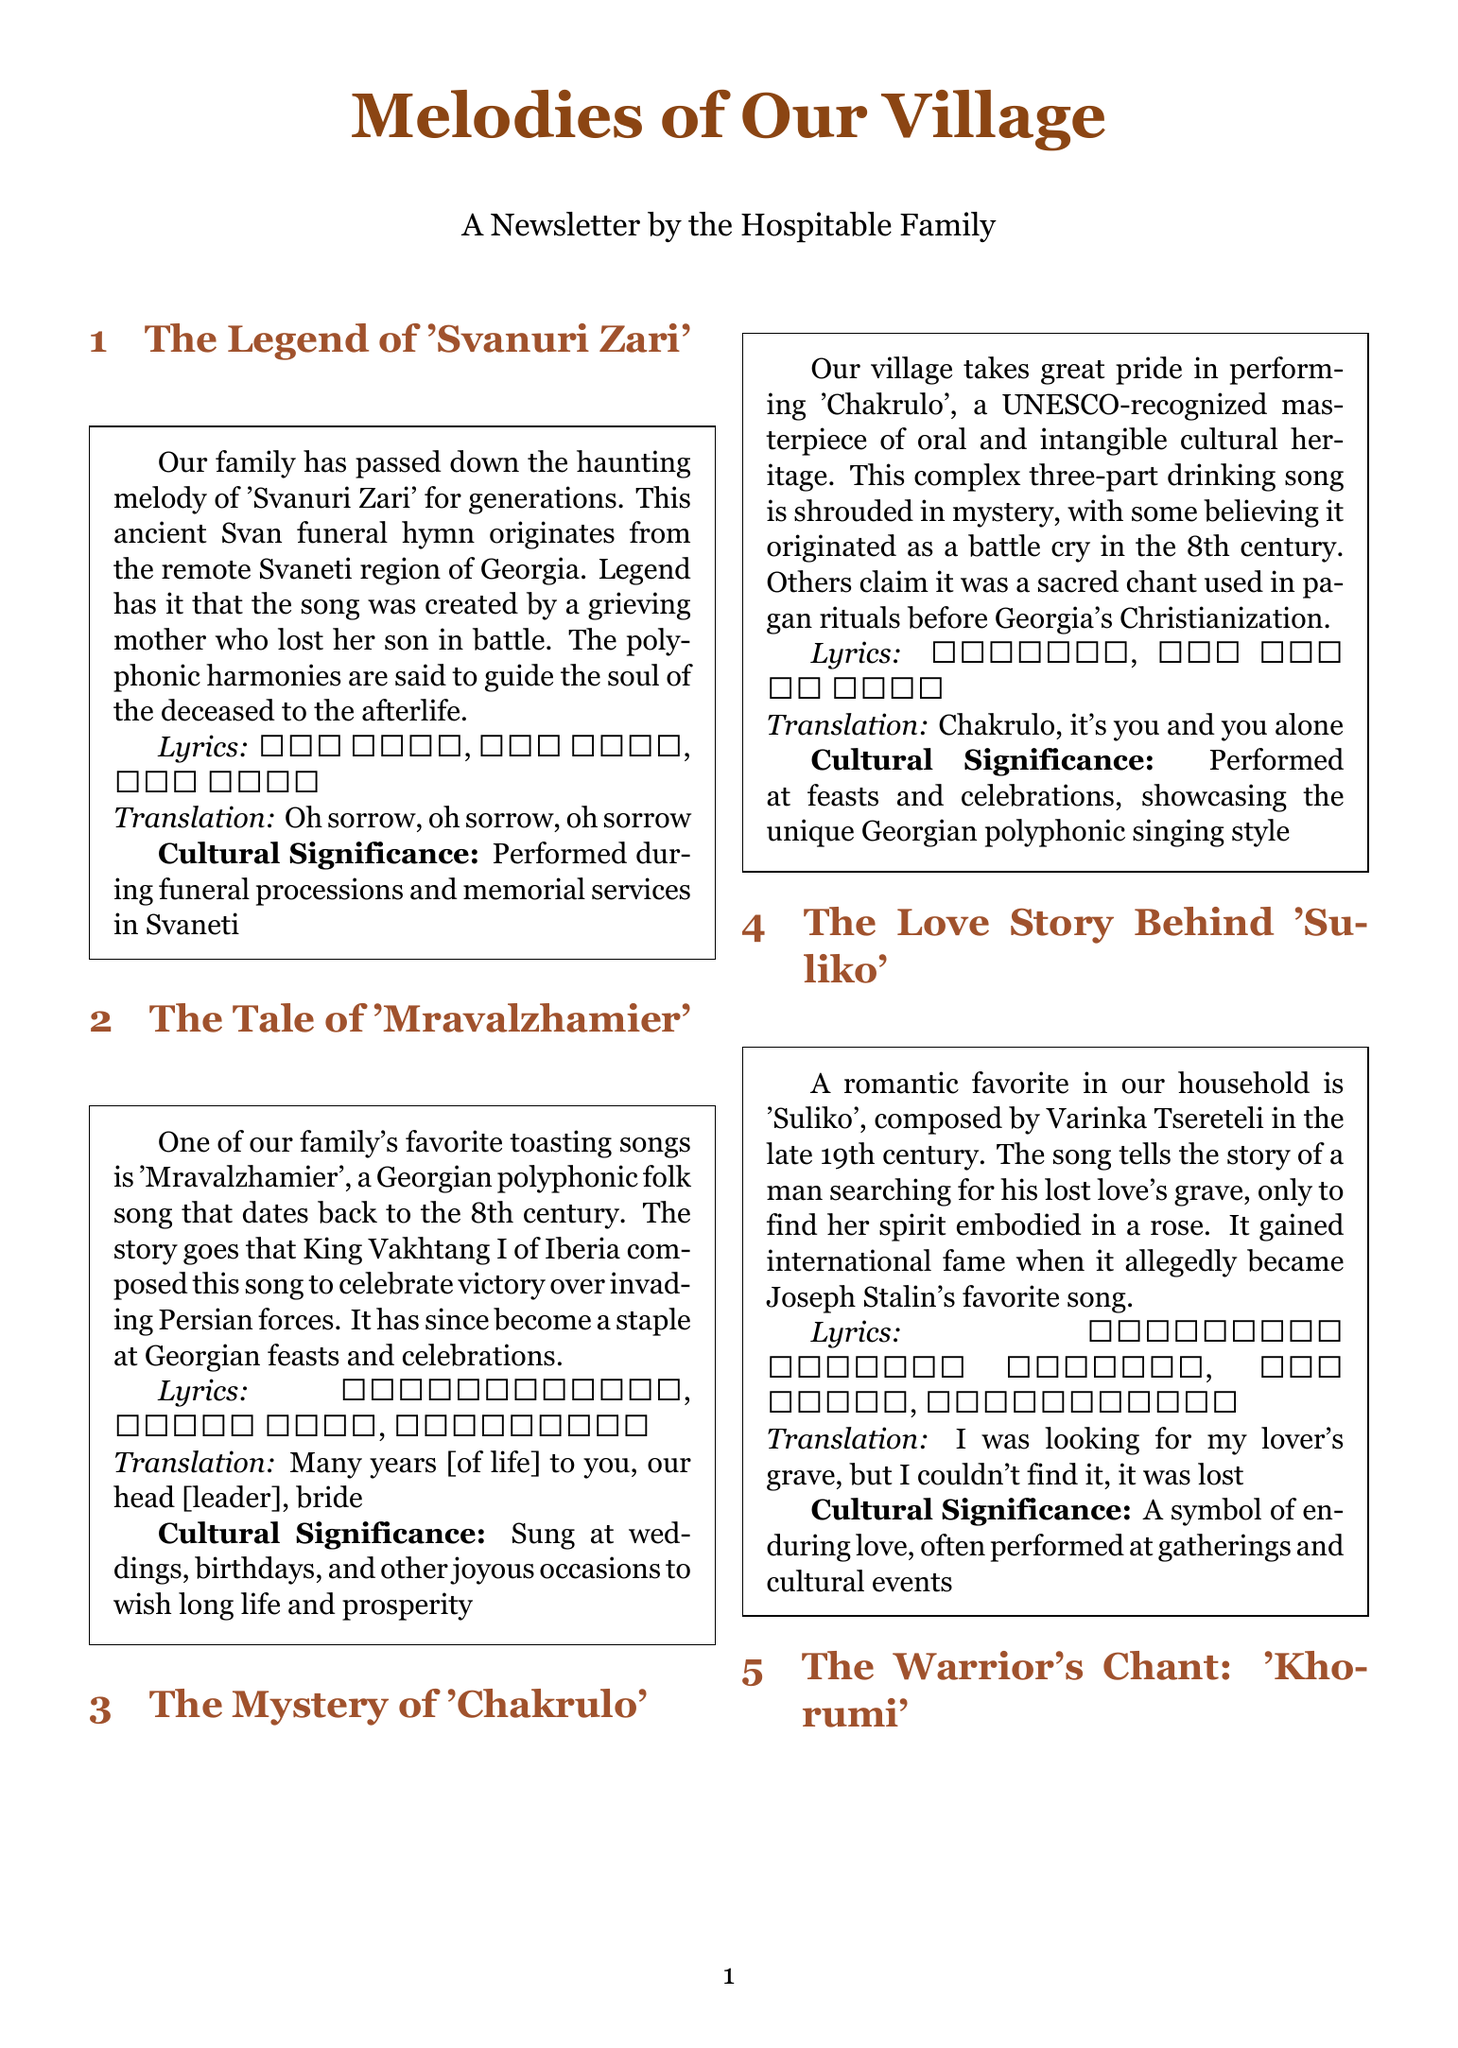What is the title of the song about a grieving mother? The song created by a grieving mother is 'Svanuri Zari'.
Answer: 'Svanuri Zari' Who composed 'Mravalzhamier'? 'Mravalzhamier' was composed by King Vakhtang I of Iberia.
Answer: King Vakhtang I What era does 'Mravalzhamier' date back to? 'Mravalzhamier' dates back to the 8th century.
Answer: 8th century What is the main theme of 'Suliko'? 'Suliko' tells the story of a man searching for his lost love's grave.
Answer: Lost love's grave Which song is recognized as a UNESCO masterpiece? The song recognized as a UNESCO masterpiece is 'Chakrulo'.
Answer: 'Chakrulo' What is performed before battles according to the legend of 'Khorumi'? 'Khorumi' is a traditional war dance performed before battles.
Answer: War dance What do the lyrics of 'Chakrulo' refer to? The lyrics of 'Chakrulo' refer to it's you and you alone.
Answer: It's you and you alone During which occasions is 'Mravalzhamier' typically sung? 'Mravalzhamier' is sung at weddings and birthdays.
Answer: Weddings and birthdays What type of singing style is showcased in 'Chakrulo'? 'Chakrulo' showcases the unique Georgian polyphonic singing style.
Answer: Georgian polyphonic singing style 